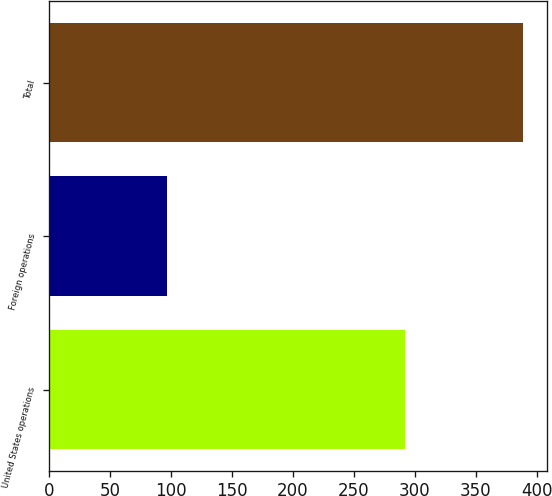Convert chart to OTSL. <chart><loc_0><loc_0><loc_500><loc_500><bar_chart><fcel>United States operations<fcel>Foreign operations<fcel>Total<nl><fcel>292<fcel>96.9<fcel>388.9<nl></chart> 